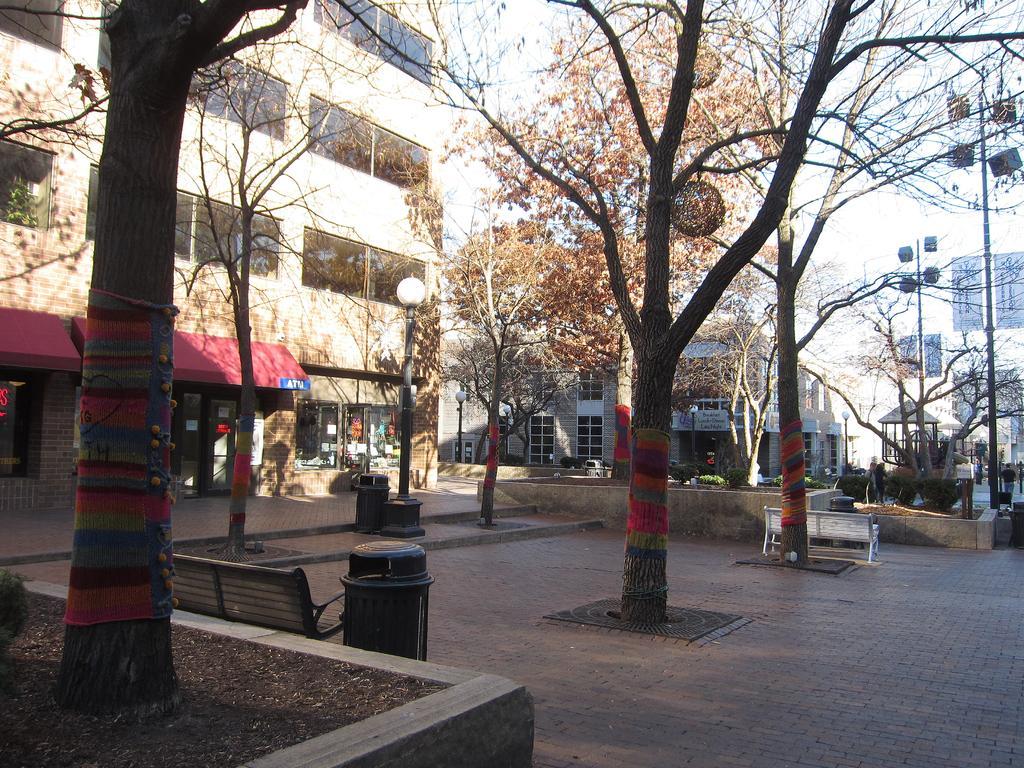Could you give a brief overview of what you see in this image? In this image we can see a group of trees and in the middle of the trees there are few benches and dustbins. Behind the trees we can see few buildings, pole with lights and on the right side of the image there are few poles and persons. At the top we can see the sky. 